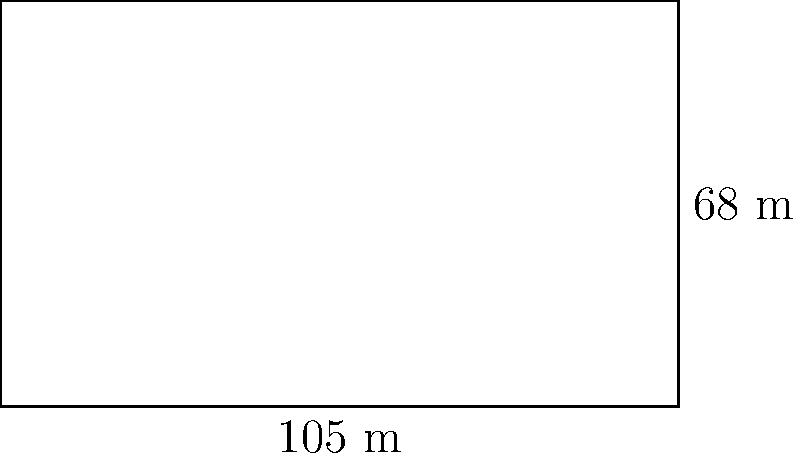As a Vatican City citizen and sports enthusiast, you're helping to organize a soccer tournament in St. Peter's Square. The field needs to be marked out, and you're in charge of calculating how much boundary tape is needed. If the soccer field measures 105 meters in length and 68 meters in width, what is the perimeter of the field? Let's approach this step-by-step:

1) The soccer field is rectangular in shape.
2) For a rectangle, the perimeter is calculated using the formula:
   $P = 2l + 2w$
   where $P$ is the perimeter, $l$ is the length, and $w$ is the width.

3) We are given:
   Length ($l$) = 105 meters
   Width ($w$) = 68 meters

4) Let's substitute these values into our formula:
   $P = 2(105) + 2(68)$

5) Now, let's calculate:
   $P = 210 + 136$
   $P = 346$

Therefore, the perimeter of the soccer field is 346 meters.
Answer: 346 meters 